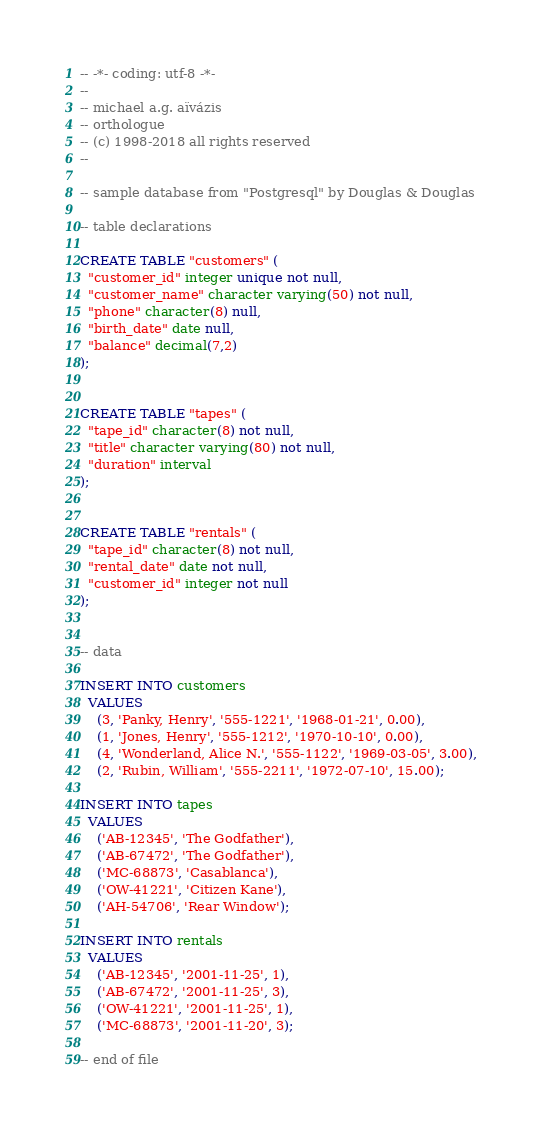Convert code to text. <code><loc_0><loc_0><loc_500><loc_500><_SQL_>-- -*- coding: utf-8 -*-
--
-- michael a.g. aïvázis
-- orthologue
-- (c) 1998-2018 all rights reserved
--

-- sample database from "Postgresql" by Douglas & Douglas

-- table declarations

CREATE TABLE "customers" (
  "customer_id" integer unique not null,
  "customer_name" character varying(50) not null,
  "phone" character(8) null,
  "birth_date" date null,
  "balance" decimal(7,2)
);


CREATE TABLE "tapes" (
  "tape_id" character(8) not null,
  "title" character varying(80) not null,
  "duration" interval
);


CREATE TABLE "rentals" (
  "tape_id" character(8) not null,
  "rental_date" date not null,
  "customer_id" integer not null
);


-- data

INSERT INTO customers
  VALUES
    (3, 'Panky, Henry', '555-1221', '1968-01-21', 0.00),
    (1, 'Jones, Henry', '555-1212', '1970-10-10', 0.00),
    (4, 'Wonderland, Alice N.', '555-1122', '1969-03-05', 3.00),
    (2, 'Rubin, William', '555-2211', '1972-07-10', 15.00);

INSERT INTO tapes
  VALUES
    ('AB-12345', 'The Godfather'),
    ('AB-67472', 'The Godfather'),
    ('MC-68873', 'Casablanca'),
    ('OW-41221', 'Citizen Kane'),
    ('AH-54706', 'Rear Window');

INSERT INTO rentals
  VALUES
    ('AB-12345', '2001-11-25', 1),
    ('AB-67472', '2001-11-25', 3),
    ('OW-41221', '2001-11-25', 1),
    ('MC-68873', '2001-11-20', 3);

-- end of file
</code> 